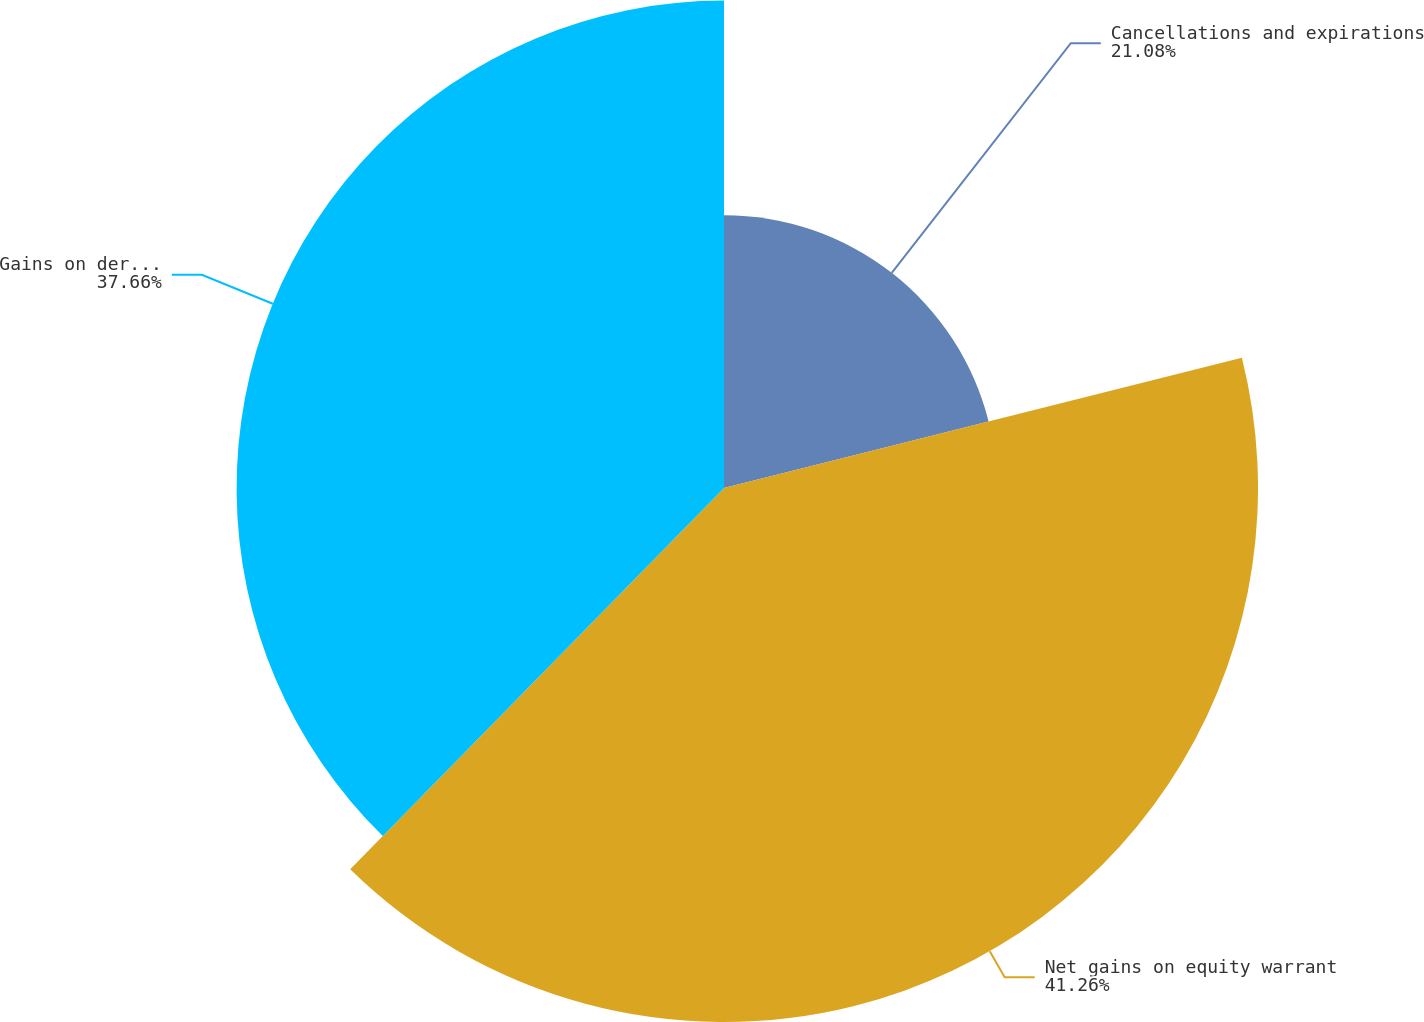Convert chart to OTSL. <chart><loc_0><loc_0><loc_500><loc_500><pie_chart><fcel>Cancellations and expirations<fcel>Net gains on equity warrant<fcel>Gains on derivative<nl><fcel>21.08%<fcel>41.26%<fcel>37.66%<nl></chart> 